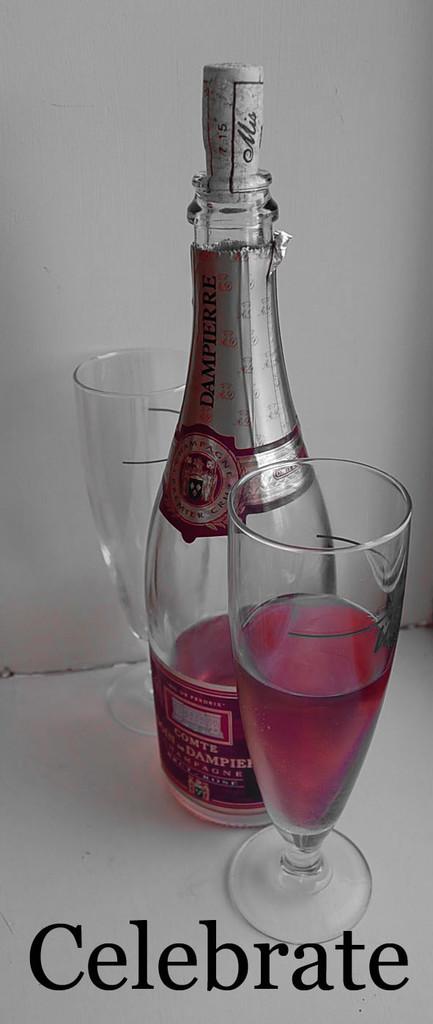What does the picture say to do?
Your answer should be compact. Celebrate. 